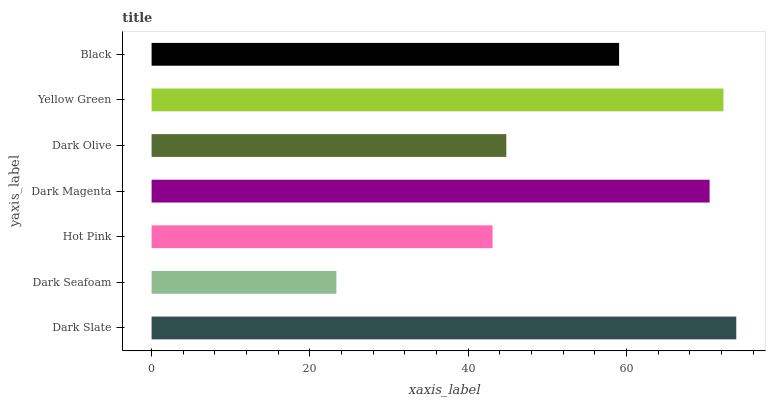Is Dark Seafoam the minimum?
Answer yes or no. Yes. Is Dark Slate the maximum?
Answer yes or no. Yes. Is Hot Pink the minimum?
Answer yes or no. No. Is Hot Pink the maximum?
Answer yes or no. No. Is Hot Pink greater than Dark Seafoam?
Answer yes or no. Yes. Is Dark Seafoam less than Hot Pink?
Answer yes or no. Yes. Is Dark Seafoam greater than Hot Pink?
Answer yes or no. No. Is Hot Pink less than Dark Seafoam?
Answer yes or no. No. Is Black the high median?
Answer yes or no. Yes. Is Black the low median?
Answer yes or no. Yes. Is Dark Slate the high median?
Answer yes or no. No. Is Dark Seafoam the low median?
Answer yes or no. No. 